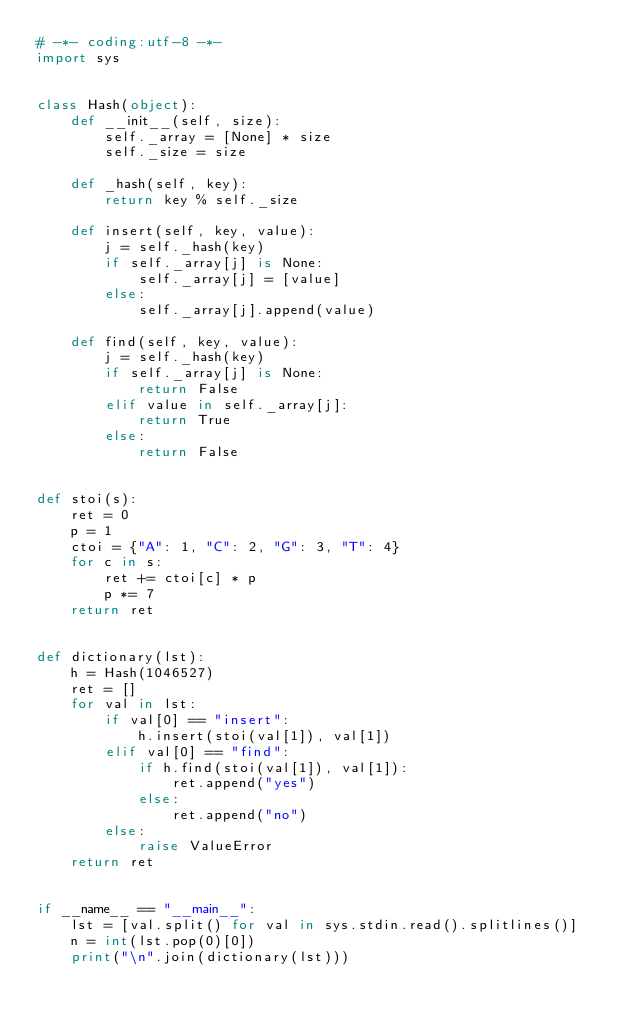<code> <loc_0><loc_0><loc_500><loc_500><_Python_># -*- coding:utf-8 -*-
import sys


class Hash(object):
    def __init__(self, size):
        self._array = [None] * size
        self._size = size

    def _hash(self, key):
        return key % self._size

    def insert(self, key, value):
        j = self._hash(key)
        if self._array[j] is None:
            self._array[j] = [value]
        else:
            self._array[j].append(value)

    def find(self, key, value):
        j = self._hash(key)
        if self._array[j] is None:
            return False
        elif value in self._array[j]:
            return True
        else:
            return False


def stoi(s):
    ret = 0
    p = 1
    ctoi = {"A": 1, "C": 2, "G": 3, "T": 4}
    for c in s:
        ret += ctoi[c] * p
        p *= 7
    return ret


def dictionary(lst):
    h = Hash(1046527)
    ret = []
    for val in lst:
        if val[0] == "insert":
            h.insert(stoi(val[1]), val[1])
        elif val[0] == "find":
            if h.find(stoi(val[1]), val[1]):
                ret.append("yes")
            else:
                ret.append("no")
        else:
            raise ValueError
    return ret


if __name__ == "__main__":
    lst = [val.split() for val in sys.stdin.read().splitlines()]
    n = int(lst.pop(0)[0])
    print("\n".join(dictionary(lst)))</code> 